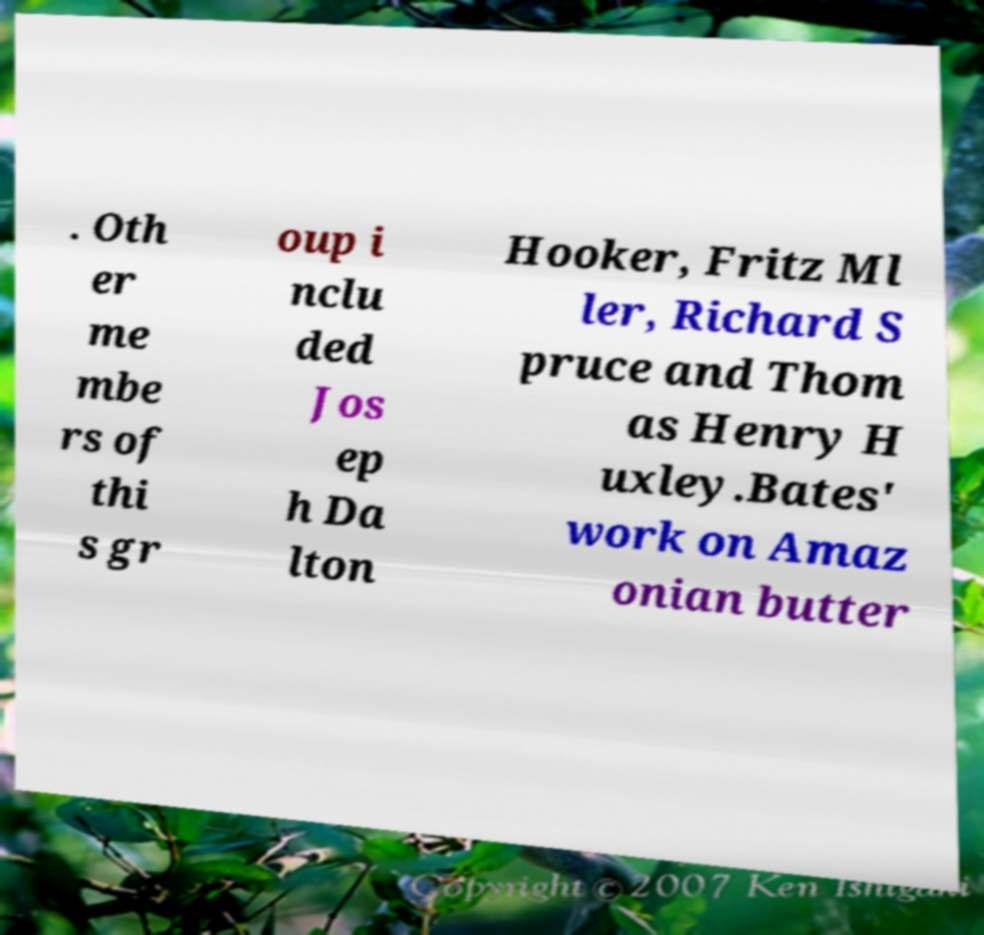For documentation purposes, I need the text within this image transcribed. Could you provide that? . Oth er me mbe rs of thi s gr oup i nclu ded Jos ep h Da lton Hooker, Fritz Ml ler, Richard S pruce and Thom as Henry H uxley.Bates' work on Amaz onian butter 